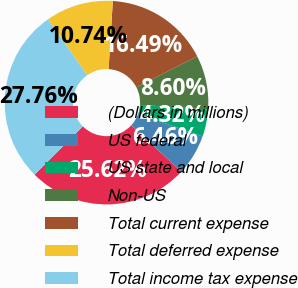Convert chart. <chart><loc_0><loc_0><loc_500><loc_500><pie_chart><fcel>(Dollars in millions)<fcel>US federal<fcel>US state and local<fcel>Non-US<fcel>Total current expense<fcel>Total deferred expense<fcel>Total income tax expense<nl><fcel>25.62%<fcel>6.46%<fcel>4.32%<fcel>8.6%<fcel>16.49%<fcel>10.74%<fcel>27.76%<nl></chart> 